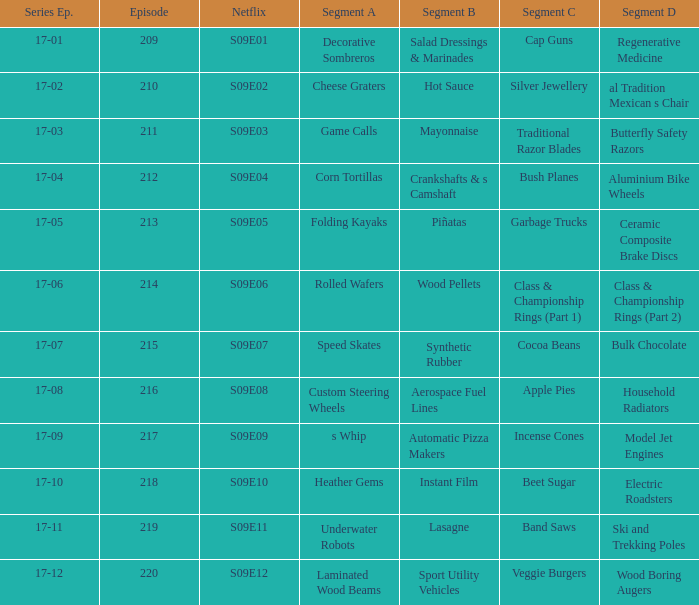How many sections include wood drilling augers? Laminated Wood Beams. 